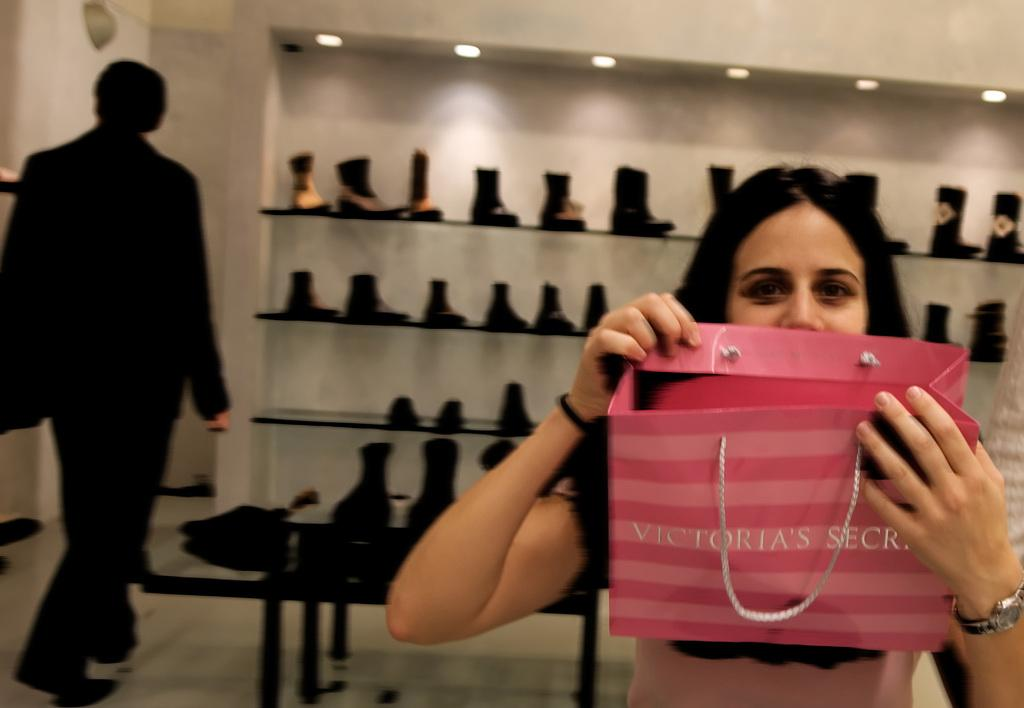Who is the main subject in the image? There is a lady in the image. What is the lady holding in the image? The lady is holding a bag. What can be seen in the background of the image? There is a man walking in the background of the image. Where are the shoes located in the image? The shoes are on a shelf in the image. What is visible at the top of the image? There are lights visible at the top of the image. What type of drawer can be seen in the image? There is no drawer present in the image. How many planes are flying in the image? There are no planes visible in the image. 